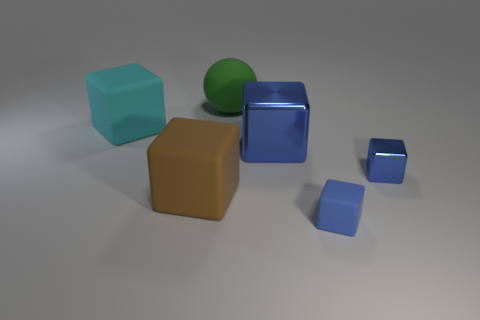Subtract all small matte blocks. How many blocks are left? 4 Subtract all brown spheres. How many blue cubes are left? 3 Subtract all cyan cubes. How many cubes are left? 4 Add 3 big green matte cylinders. How many objects exist? 9 Subtract all spheres. How many objects are left? 5 Subtract all gray blocks. Subtract all blue cylinders. How many blocks are left? 5 Subtract all small matte objects. Subtract all blue balls. How many objects are left? 5 Add 4 small blocks. How many small blocks are left? 6 Add 5 cyan cylinders. How many cyan cylinders exist? 5 Subtract 0 yellow cubes. How many objects are left? 6 